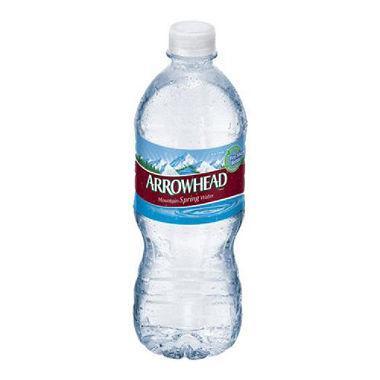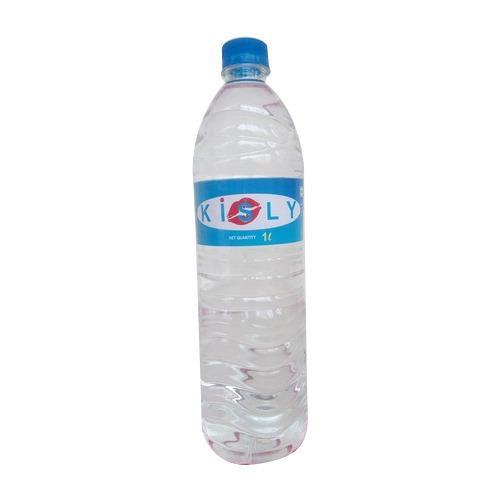The first image is the image on the left, the second image is the image on the right. Assess this claim about the two images: "One of the bottles is near an ice tray.". Correct or not? Answer yes or no. No. The first image is the image on the left, the second image is the image on the right. Given the left and right images, does the statement "An image shows some type of freezing sticks next to a water bottle." hold true? Answer yes or no. No. 